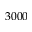<formula> <loc_0><loc_0><loc_500><loc_500>3 0 0 0</formula> 